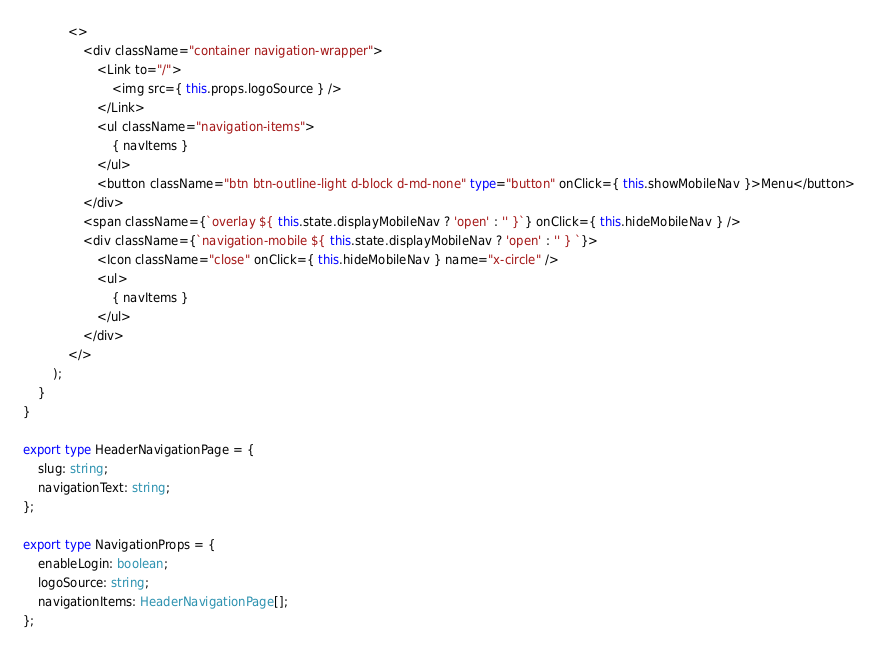Convert code to text. <code><loc_0><loc_0><loc_500><loc_500><_TypeScript_>            <>
                <div className="container navigation-wrapper">
                    <Link to="/">
                        <img src={ this.props.logoSource } />
                    </Link>
                    <ul className="navigation-items">
                        { navItems }
                    </ul>
                    <button className="btn btn-outline-light d-block d-md-none" type="button" onClick={ this.showMobileNav }>Menu</button>
                </div>
                <span className={`overlay ${ this.state.displayMobileNav ? 'open' : '' }`} onClick={ this.hideMobileNav } />
                <div className={`navigation-mobile ${ this.state.displayMobileNav ? 'open' : '' } `}>
                    <Icon className="close" onClick={ this.hideMobileNav } name="x-circle" />
                    <ul>
                        { navItems }
                    </ul>
                </div>
            </>
        );
    }
}

export type HeaderNavigationPage = {
    slug: string;
    navigationText: string;
};

export type NavigationProps = {
    enableLogin: boolean;
    logoSource: string;
    navigationItems: HeaderNavigationPage[];
};</code> 